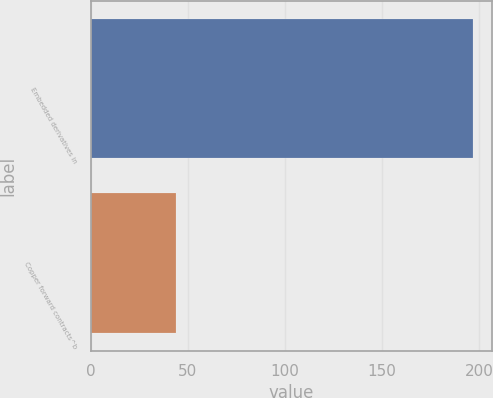<chart> <loc_0><loc_0><loc_500><loc_500><bar_chart><fcel>Embedded derivatives in<fcel>Copper forward contracts^b<nl><fcel>197<fcel>44<nl></chart> 